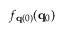Convert formula to latex. <formula><loc_0><loc_0><loc_500><loc_500>f _ { { q } ( 0 ) } ( { q } _ { 0 } )</formula> 